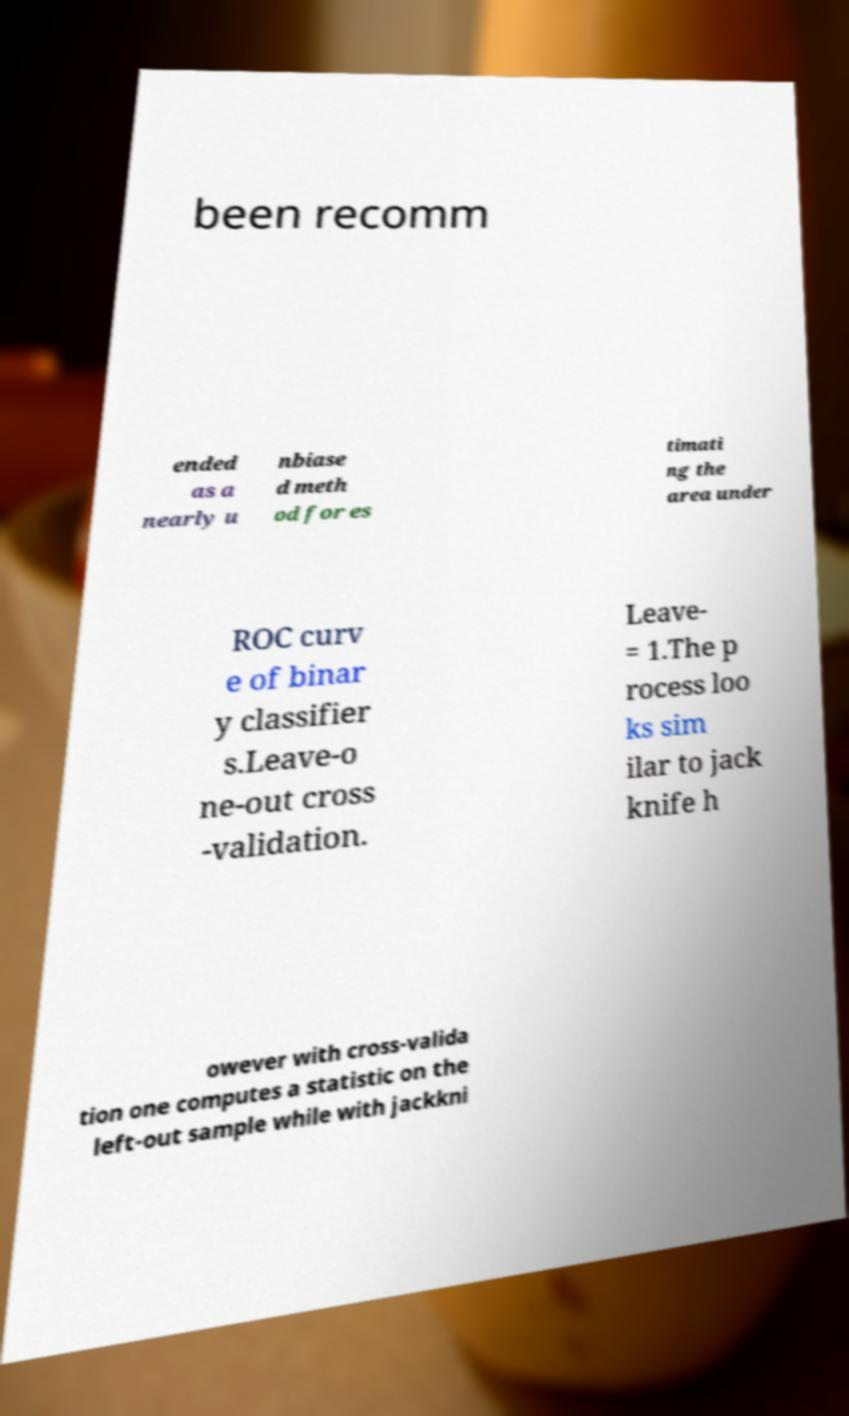For documentation purposes, I need the text within this image transcribed. Could you provide that? been recomm ended as a nearly u nbiase d meth od for es timati ng the area under ROC curv e of binar y classifier s.Leave-o ne-out cross -validation. Leave- = 1.The p rocess loo ks sim ilar to jack knife h owever with cross-valida tion one computes a statistic on the left-out sample while with jackkni 